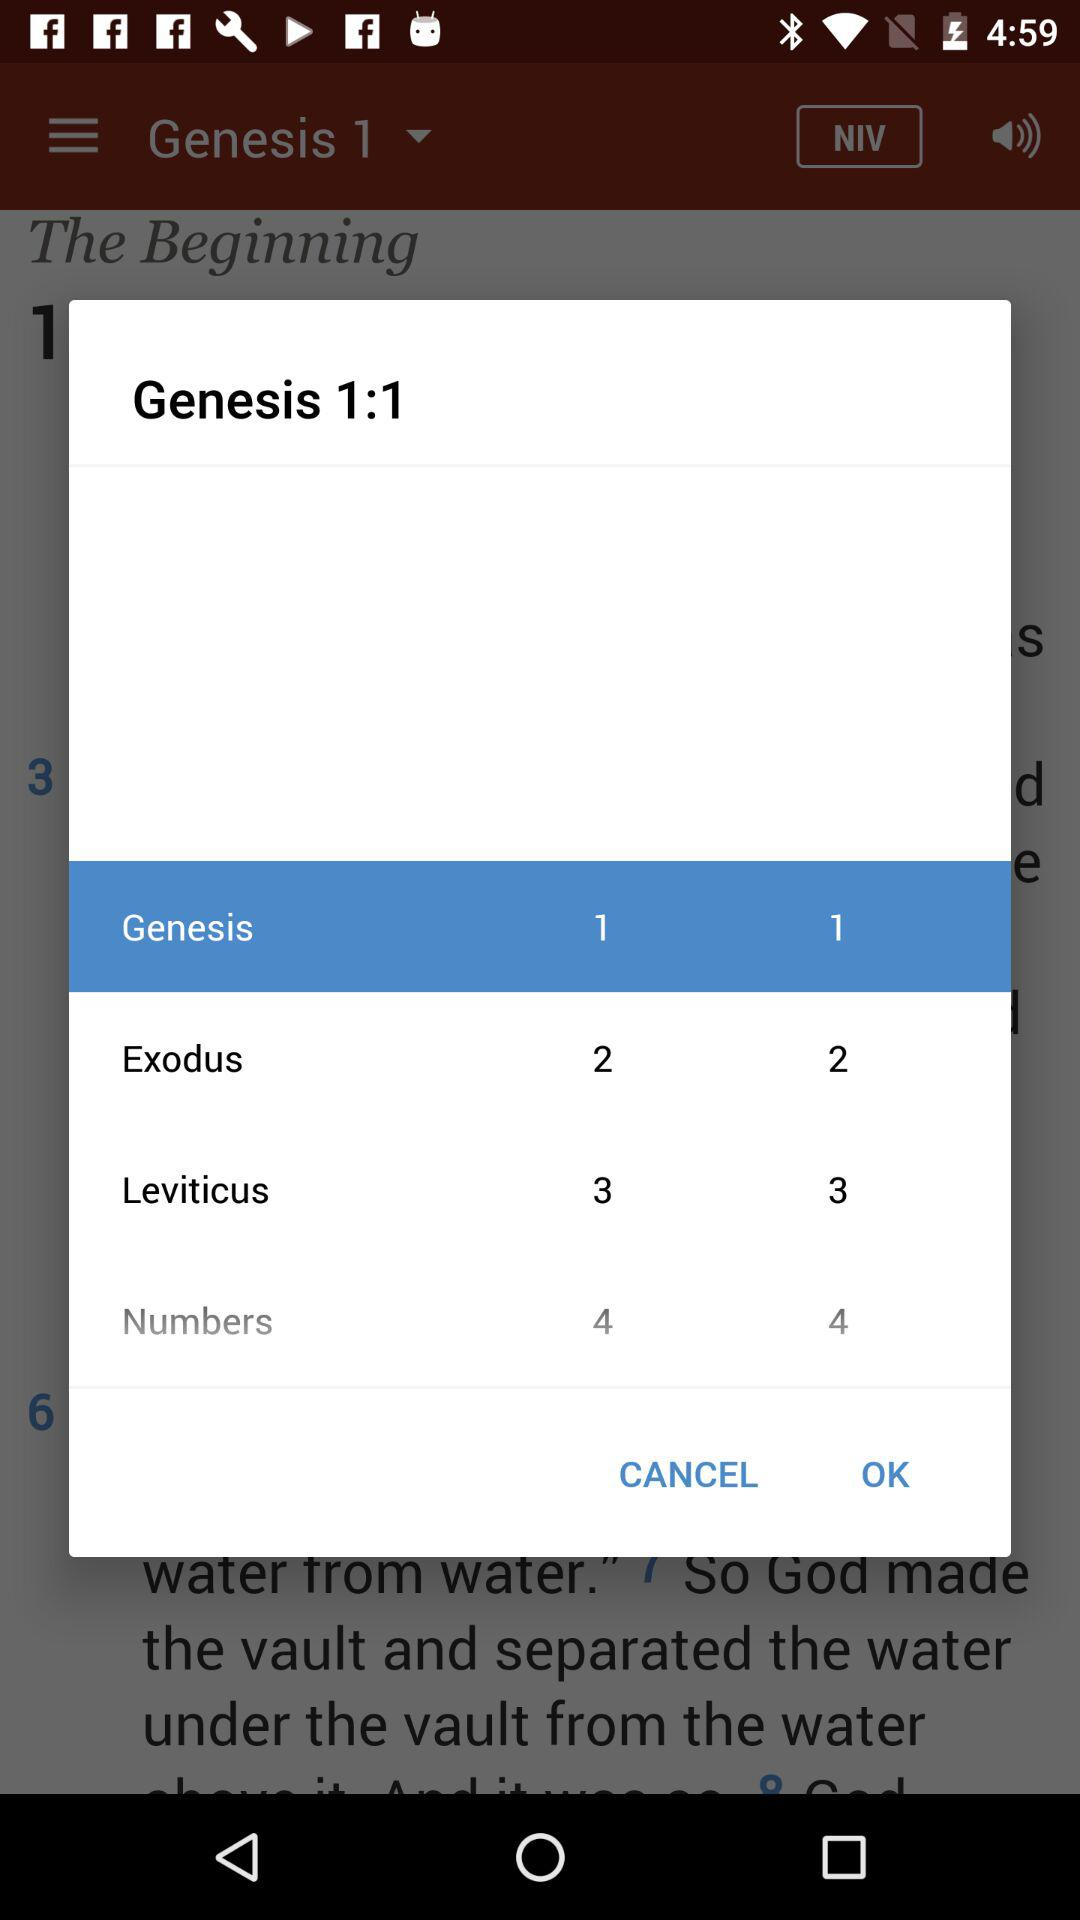What is the ratio of Genesis?
When the provided information is insufficient, respond with <no answer>. <no answer> 